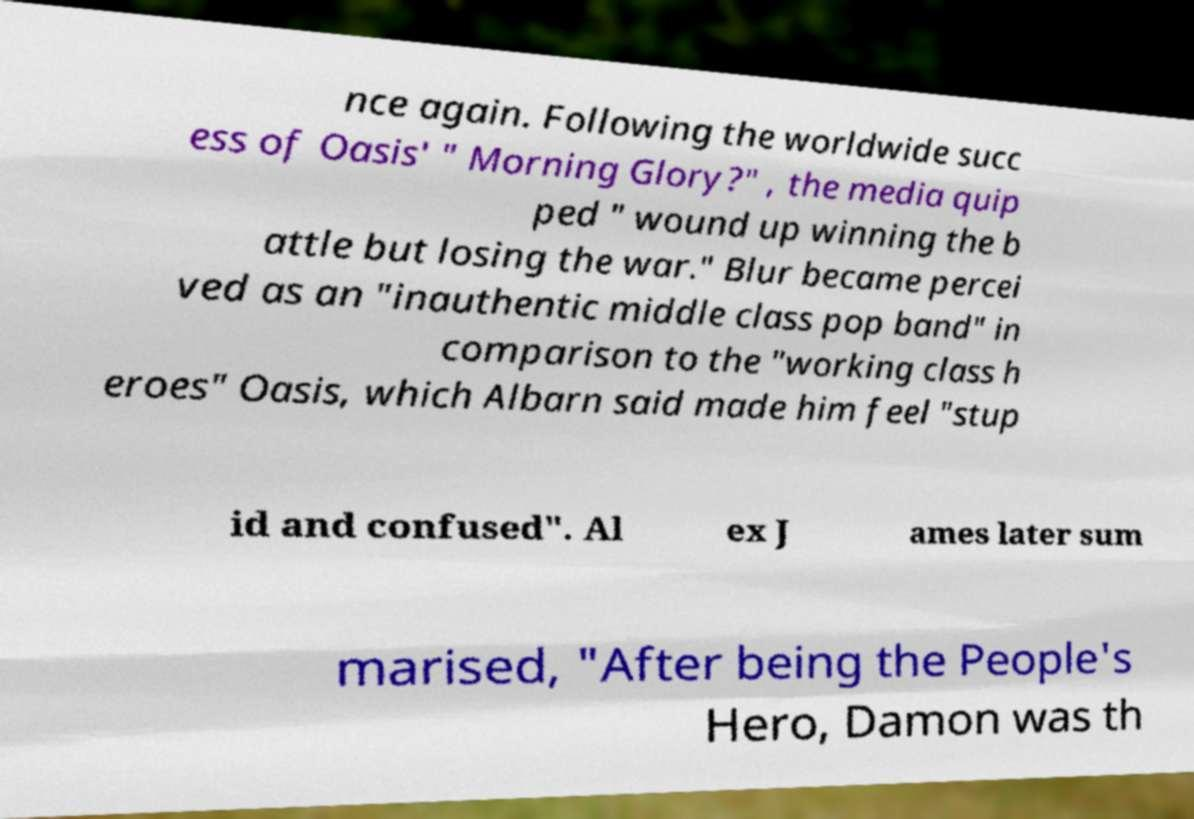Could you assist in decoding the text presented in this image and type it out clearly? nce again. Following the worldwide succ ess of Oasis' " Morning Glory?" , the media quip ped " wound up winning the b attle but losing the war." Blur became percei ved as an "inauthentic middle class pop band" in comparison to the "working class h eroes" Oasis, which Albarn said made him feel "stup id and confused". Al ex J ames later sum marised, "After being the People's Hero, Damon was th 